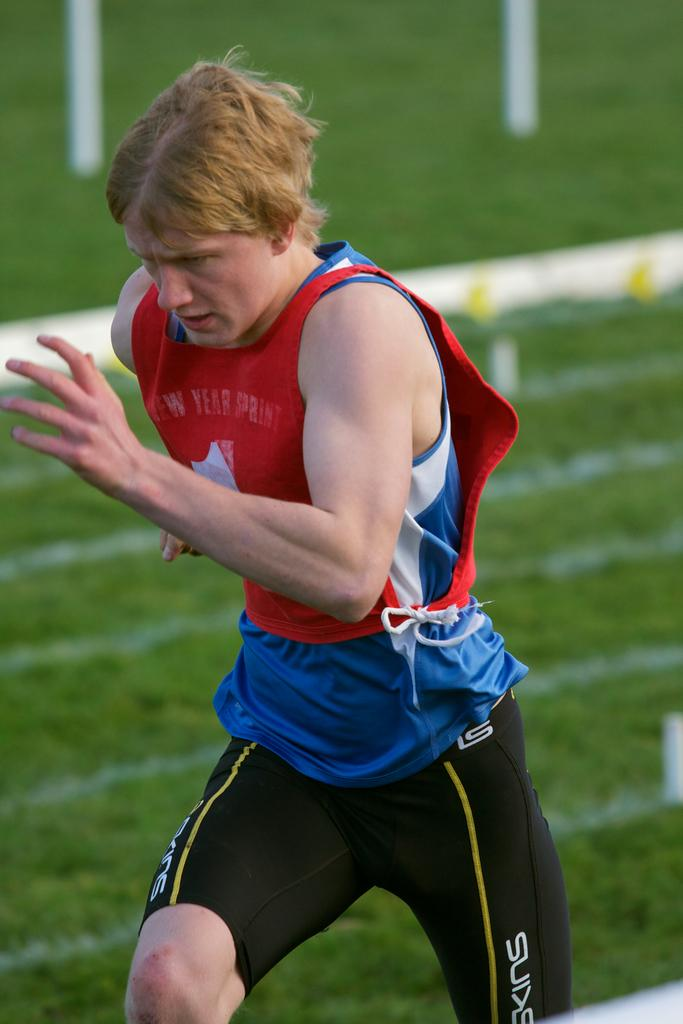<image>
Describe the image concisely. A man runs quickly on a field for the New Year Sprint. 